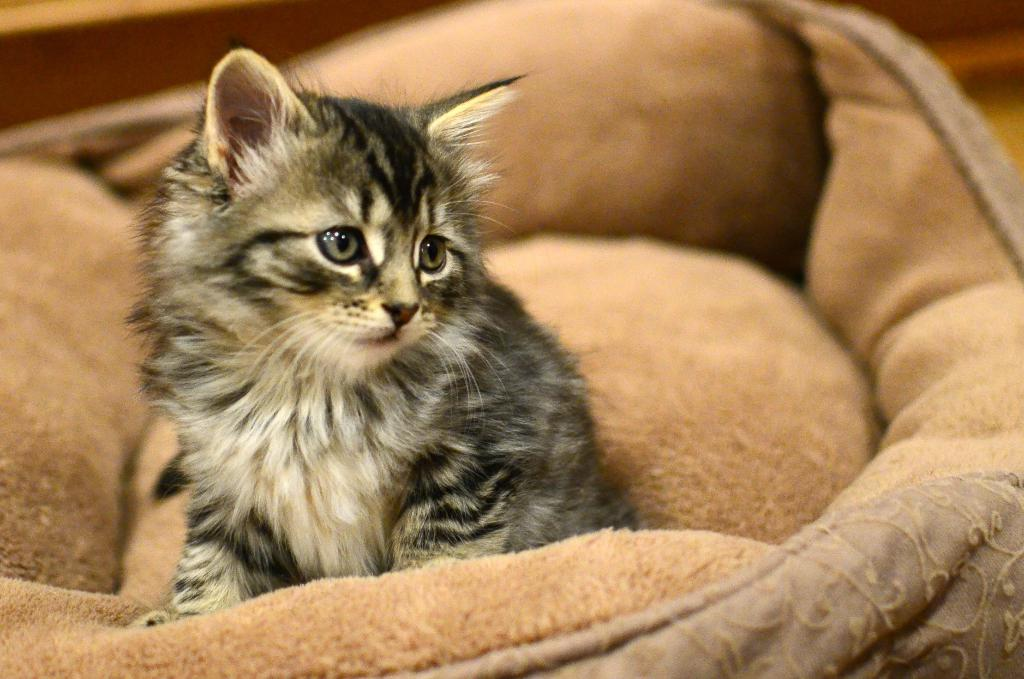What type of animal is in the image? There is a cat in the image. Can you describe the coloring of the cat? The cat has white and black coloring. Where is the cat located in the image? The cat is on a brown-colored bed. What color is the door in the image? There is no door present in the image; it only features a cat on a brown-colored bed. 